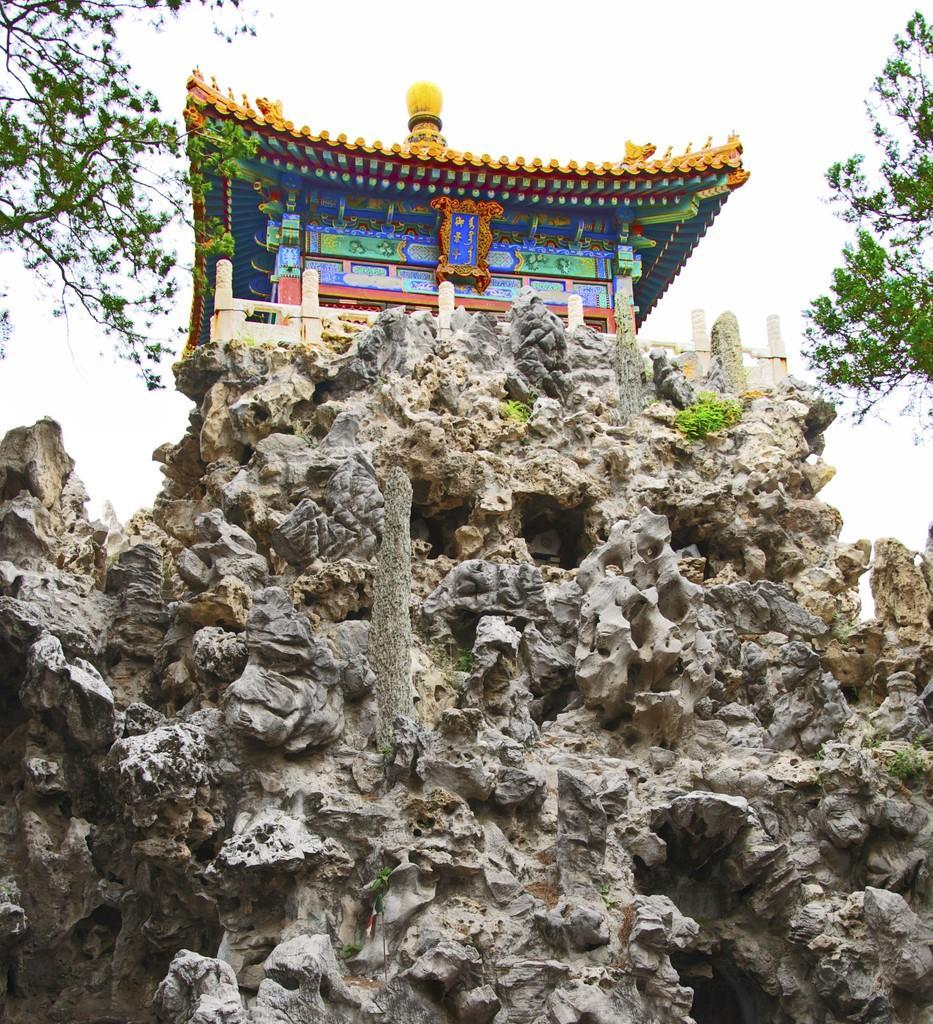How would you summarize this image in a sentence or two? In the foreground of the picture there is rock. In the center of the picture there is a building. On the left there is a tree. On the right there is a tree. In the background it is sky. 